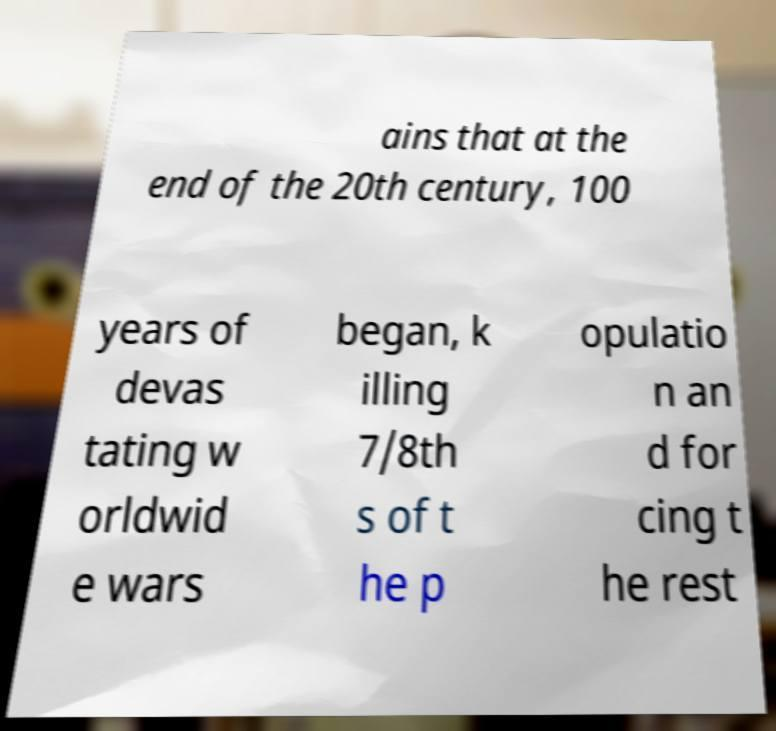For documentation purposes, I need the text within this image transcribed. Could you provide that? ains that at the end of the 20th century, 100 years of devas tating w orldwid e wars began, k illing 7/8th s of t he p opulatio n an d for cing t he rest 